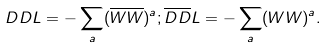<formula> <loc_0><loc_0><loc_500><loc_500>D D L = - \sum _ { a } ( \overline { W W } ) ^ { a } ; \overline { D D } L = - \sum _ { a } ( W W ) ^ { a } .</formula> 